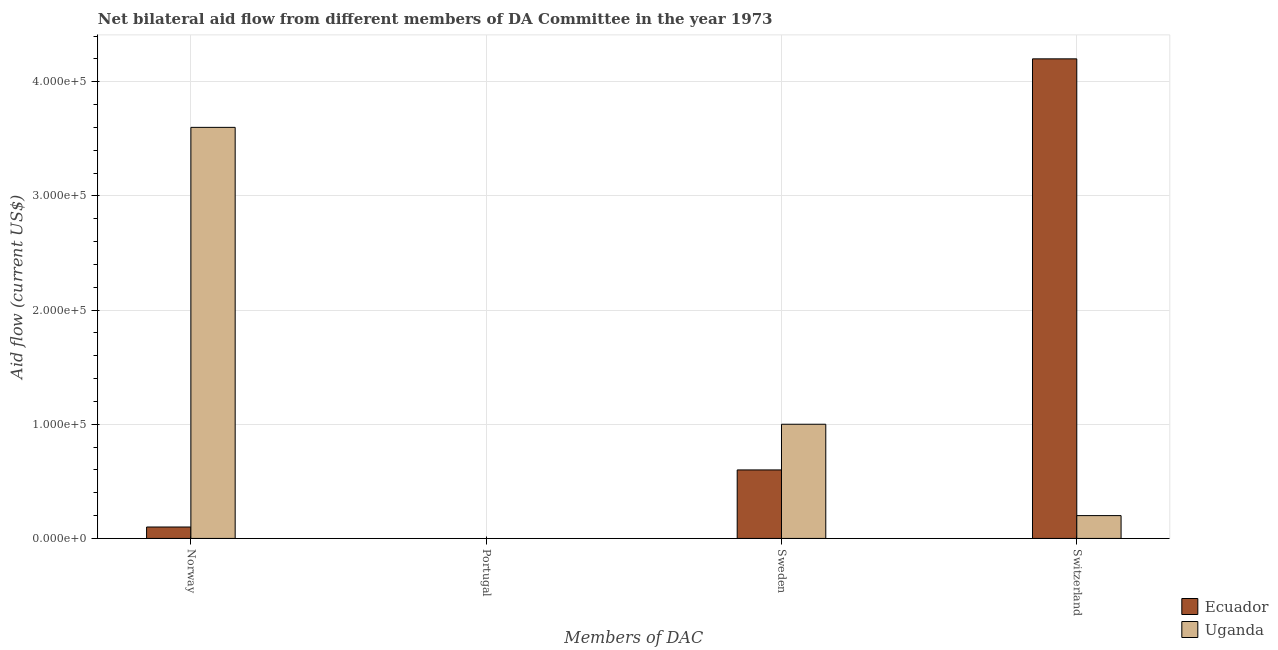How many different coloured bars are there?
Provide a short and direct response. 2. Are the number of bars per tick equal to the number of legend labels?
Provide a succinct answer. No. Are the number of bars on each tick of the X-axis equal?
Give a very brief answer. No. How many bars are there on the 3rd tick from the left?
Give a very brief answer. 2. Across all countries, what is the maximum amount of aid given by norway?
Provide a short and direct response. 3.60e+05. In which country was the amount of aid given by switzerland maximum?
Provide a short and direct response. Ecuador. What is the difference between the amount of aid given by norway in Ecuador and that in Uganda?
Your response must be concise. -3.50e+05. What is the difference between the amount of aid given by portugal in Uganda and the amount of aid given by switzerland in Ecuador?
Offer a terse response. -4.20e+05. What is the average amount of aid given by norway per country?
Make the answer very short. 1.85e+05. In how many countries, is the amount of aid given by sweden greater than 280000 US$?
Make the answer very short. 0. What is the difference between the highest and the second highest amount of aid given by sweden?
Your response must be concise. 4.00e+04. What is the difference between the highest and the lowest amount of aid given by sweden?
Offer a very short reply. 4.00e+04. Is the sum of the amount of aid given by sweden in Ecuador and Uganda greater than the maximum amount of aid given by switzerland across all countries?
Give a very brief answer. No. Are the values on the major ticks of Y-axis written in scientific E-notation?
Your answer should be very brief. Yes. Does the graph contain any zero values?
Offer a very short reply. Yes. Where does the legend appear in the graph?
Your answer should be compact. Bottom right. How are the legend labels stacked?
Offer a very short reply. Vertical. What is the title of the graph?
Offer a terse response. Net bilateral aid flow from different members of DA Committee in the year 1973. What is the label or title of the X-axis?
Ensure brevity in your answer.  Members of DAC. What is the Aid flow (current US$) of Ecuador in Norway?
Offer a very short reply. 10000. What is the Aid flow (current US$) in Uganda in Norway?
Offer a very short reply. 3.60e+05. What is the Aid flow (current US$) in Ecuador in Portugal?
Make the answer very short. Nan. What is the Aid flow (current US$) in Uganda in Portugal?
Offer a very short reply. Nan. What is the Aid flow (current US$) of Ecuador in Sweden?
Keep it short and to the point. 6.00e+04. What is the Aid flow (current US$) of Ecuador in Switzerland?
Provide a succinct answer. 4.20e+05. Across all Members of DAC, what is the maximum Aid flow (current US$) in Ecuador?
Ensure brevity in your answer.  4.20e+05. Across all Members of DAC, what is the maximum Aid flow (current US$) of Uganda?
Keep it short and to the point. 3.60e+05. Across all Members of DAC, what is the minimum Aid flow (current US$) in Ecuador?
Provide a succinct answer. 10000. Across all Members of DAC, what is the minimum Aid flow (current US$) of Uganda?
Your answer should be very brief. 2.00e+04. What is the total Aid flow (current US$) in Ecuador in the graph?
Keep it short and to the point. 4.90e+05. What is the total Aid flow (current US$) of Uganda in the graph?
Your answer should be very brief. 4.80e+05. What is the difference between the Aid flow (current US$) in Ecuador in Norway and that in Portugal?
Your response must be concise. Nan. What is the difference between the Aid flow (current US$) in Uganda in Norway and that in Portugal?
Your answer should be compact. Nan. What is the difference between the Aid flow (current US$) in Uganda in Norway and that in Sweden?
Provide a short and direct response. 2.60e+05. What is the difference between the Aid flow (current US$) in Ecuador in Norway and that in Switzerland?
Offer a very short reply. -4.10e+05. What is the difference between the Aid flow (current US$) in Ecuador in Portugal and that in Sweden?
Make the answer very short. Nan. What is the difference between the Aid flow (current US$) of Uganda in Portugal and that in Sweden?
Ensure brevity in your answer.  Nan. What is the difference between the Aid flow (current US$) in Ecuador in Portugal and that in Switzerland?
Your answer should be compact. Nan. What is the difference between the Aid flow (current US$) in Uganda in Portugal and that in Switzerland?
Offer a terse response. Nan. What is the difference between the Aid flow (current US$) in Ecuador in Sweden and that in Switzerland?
Your answer should be very brief. -3.60e+05. What is the difference between the Aid flow (current US$) of Uganda in Sweden and that in Switzerland?
Your response must be concise. 8.00e+04. What is the difference between the Aid flow (current US$) in Ecuador in Norway and the Aid flow (current US$) in Uganda in Portugal?
Keep it short and to the point. Nan. What is the difference between the Aid flow (current US$) of Ecuador in Portugal and the Aid flow (current US$) of Uganda in Sweden?
Give a very brief answer. Nan. What is the difference between the Aid flow (current US$) of Ecuador in Portugal and the Aid flow (current US$) of Uganda in Switzerland?
Offer a terse response. Nan. What is the average Aid flow (current US$) in Ecuador per Members of DAC?
Your answer should be very brief. 1.22e+05. What is the average Aid flow (current US$) of Uganda per Members of DAC?
Give a very brief answer. 1.20e+05. What is the difference between the Aid flow (current US$) in Ecuador and Aid flow (current US$) in Uganda in Norway?
Give a very brief answer. -3.50e+05. What is the difference between the Aid flow (current US$) in Ecuador and Aid flow (current US$) in Uganda in Portugal?
Offer a very short reply. Nan. What is the difference between the Aid flow (current US$) of Ecuador and Aid flow (current US$) of Uganda in Switzerland?
Offer a very short reply. 4.00e+05. What is the ratio of the Aid flow (current US$) in Ecuador in Norway to that in Portugal?
Your answer should be compact. Nan. What is the ratio of the Aid flow (current US$) of Uganda in Norway to that in Portugal?
Your answer should be compact. Nan. What is the ratio of the Aid flow (current US$) of Uganda in Norway to that in Sweden?
Your answer should be compact. 3.6. What is the ratio of the Aid flow (current US$) of Ecuador in Norway to that in Switzerland?
Your answer should be very brief. 0.02. What is the ratio of the Aid flow (current US$) in Ecuador in Portugal to that in Sweden?
Make the answer very short. Nan. What is the ratio of the Aid flow (current US$) in Uganda in Portugal to that in Sweden?
Offer a very short reply. Nan. What is the ratio of the Aid flow (current US$) of Ecuador in Portugal to that in Switzerland?
Your answer should be very brief. Nan. What is the ratio of the Aid flow (current US$) in Uganda in Portugal to that in Switzerland?
Your response must be concise. Nan. What is the ratio of the Aid flow (current US$) in Ecuador in Sweden to that in Switzerland?
Your answer should be compact. 0.14. What is the ratio of the Aid flow (current US$) in Uganda in Sweden to that in Switzerland?
Ensure brevity in your answer.  5. What is the difference between the highest and the lowest Aid flow (current US$) of Ecuador?
Offer a very short reply. 4.10e+05. What is the difference between the highest and the lowest Aid flow (current US$) of Uganda?
Make the answer very short. 3.40e+05. 